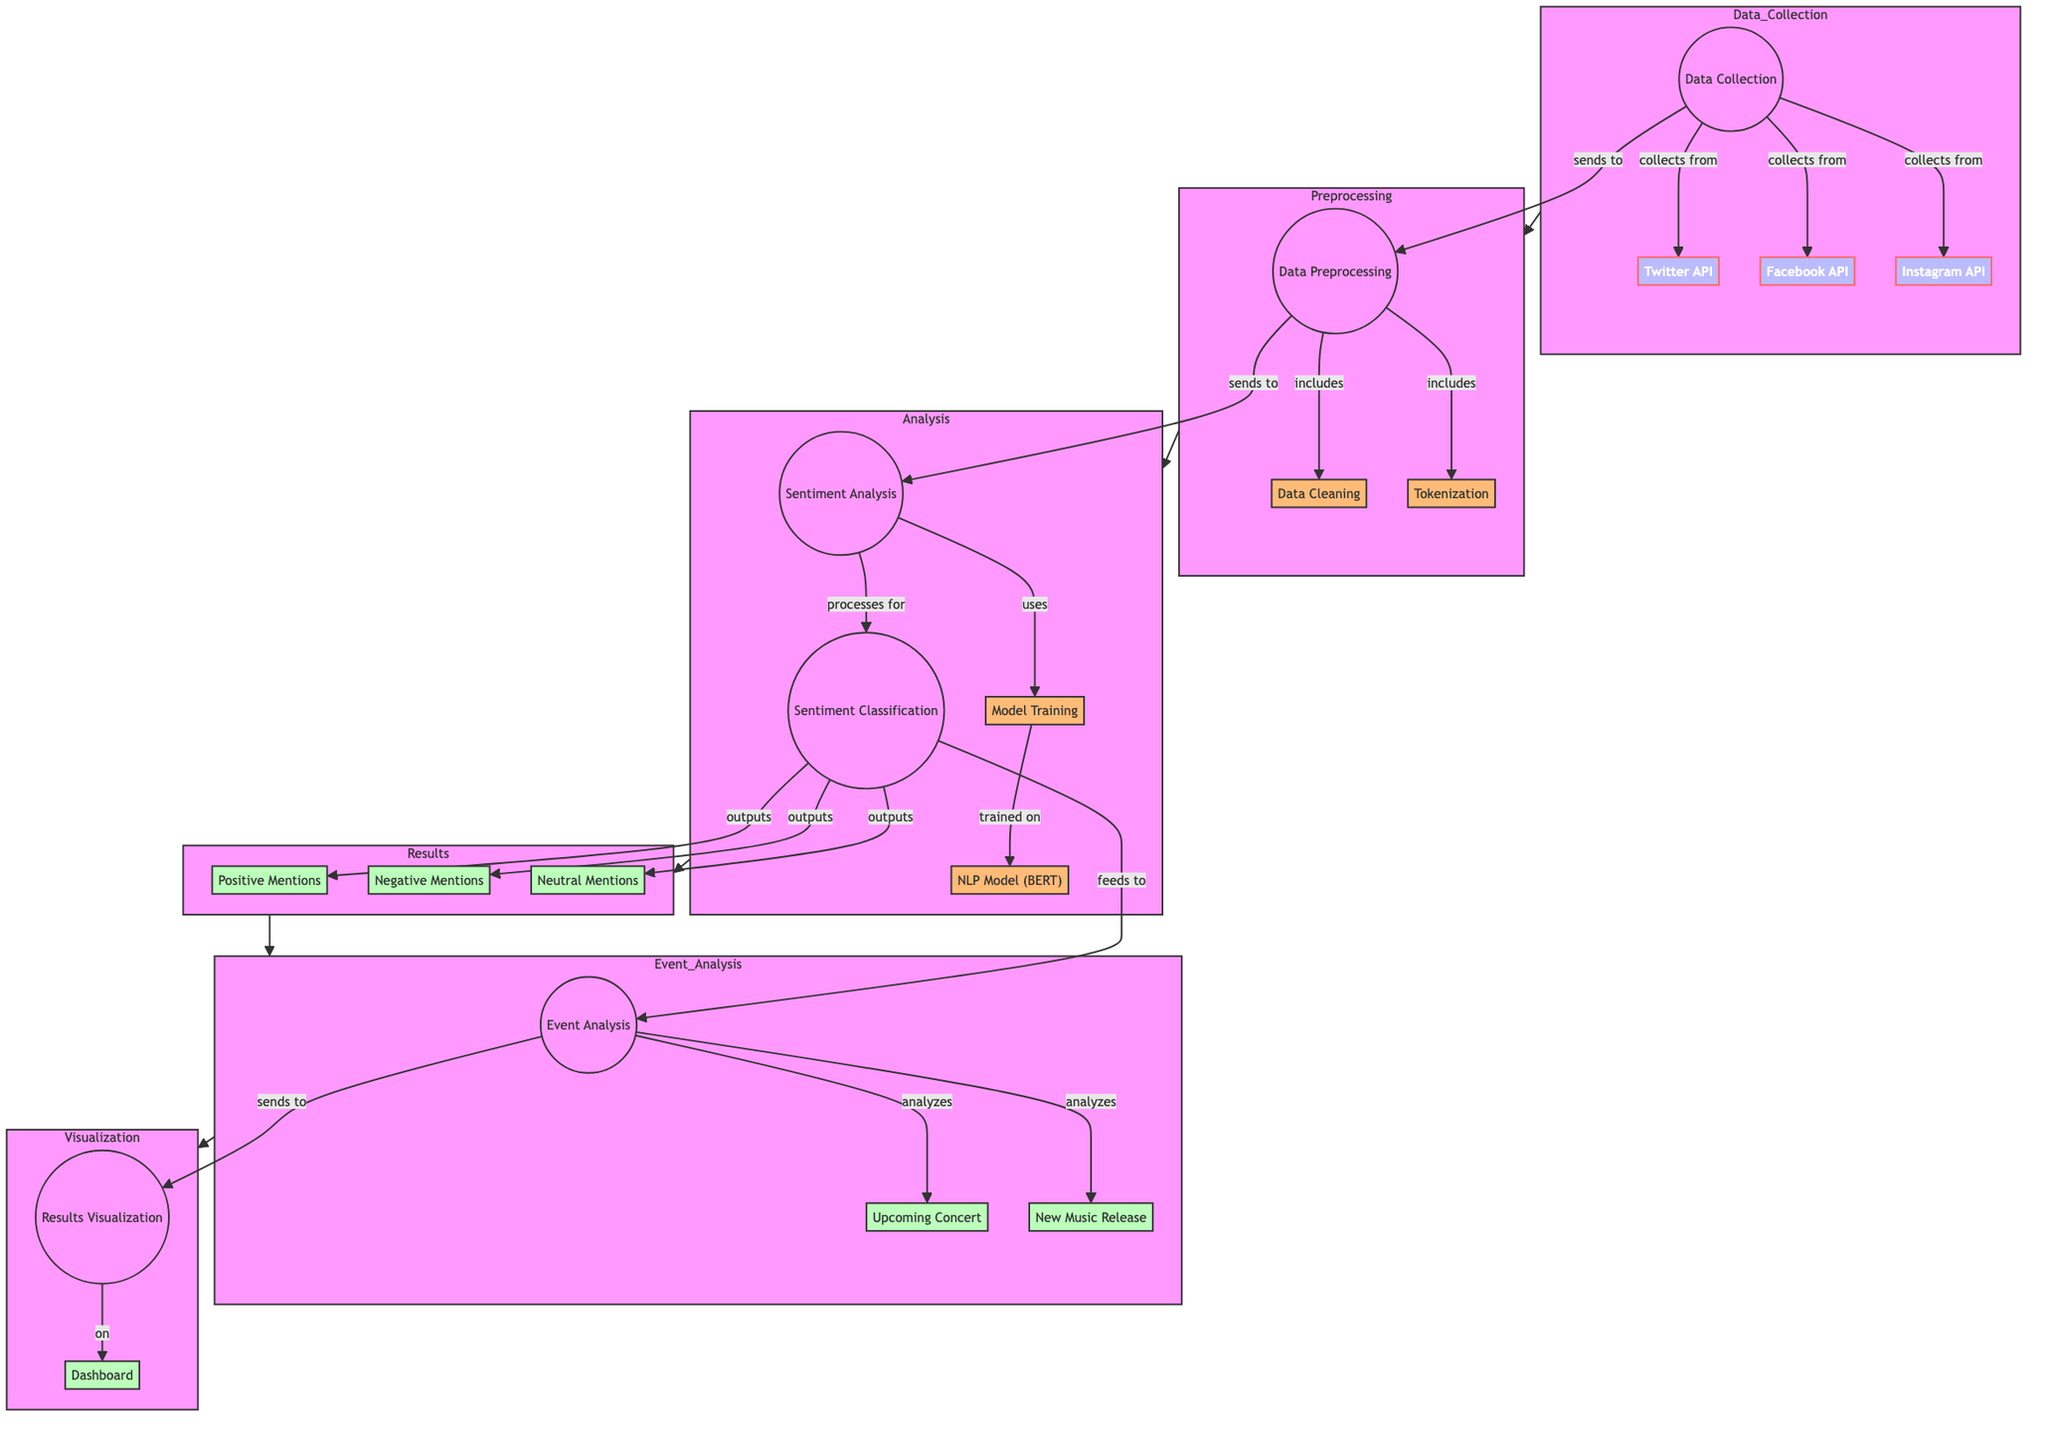What is the first step in the diagram? The diagram begins with "Data Collection", indicating it is the first step in the workflow.
Answer: Data Collection How many social media APIs are used for data collection? There are three APIs used for data collection: Twitter API, Facebook API, and Instagram API.
Answer: Three What does the preprocessing step include? The preprocessing step includes "Data Cleaning" and "Tokenization" based on the diagram's connections.
Answer: Data Cleaning, Tokenization What is the output of the sentiment classification? The sentiment classification outputs three categories: Positive Mentions, Negative Mentions, and Neutral Mentions.
Answer: Positive Mentions, Negative Mentions, Neutral Mentions Which node feeds into the event analysis? The "Sentiment Classification" node feeds into the "Event Analysis" node, providing sentiment data for upcoming events and music releases.
Answer: Sentiment Classification How many nodes are part of the results subgraph? The results subgraph consists of three nodes: Positive Mentions, Negative Mentions, and Neutral Mentions, with no additional nodes indicated.
Answer: Three What machine learning model is used in the analysis? The analysis utilizes the "NLP Model (BERT)" for sentiment analysis in the workflow.
Answer: NLP Model (BERT) What is analyzed under event analysis? The event analysis specifically analyzes "Upcoming Concert" and "New Music Release" as per the diagram's details.
Answer: Upcoming Concert, New Music Release What does the results visualization connect to? The "Results Visualization" node connects to the "Dashboard", indicating that final results are presented there.
Answer: Dashboard 